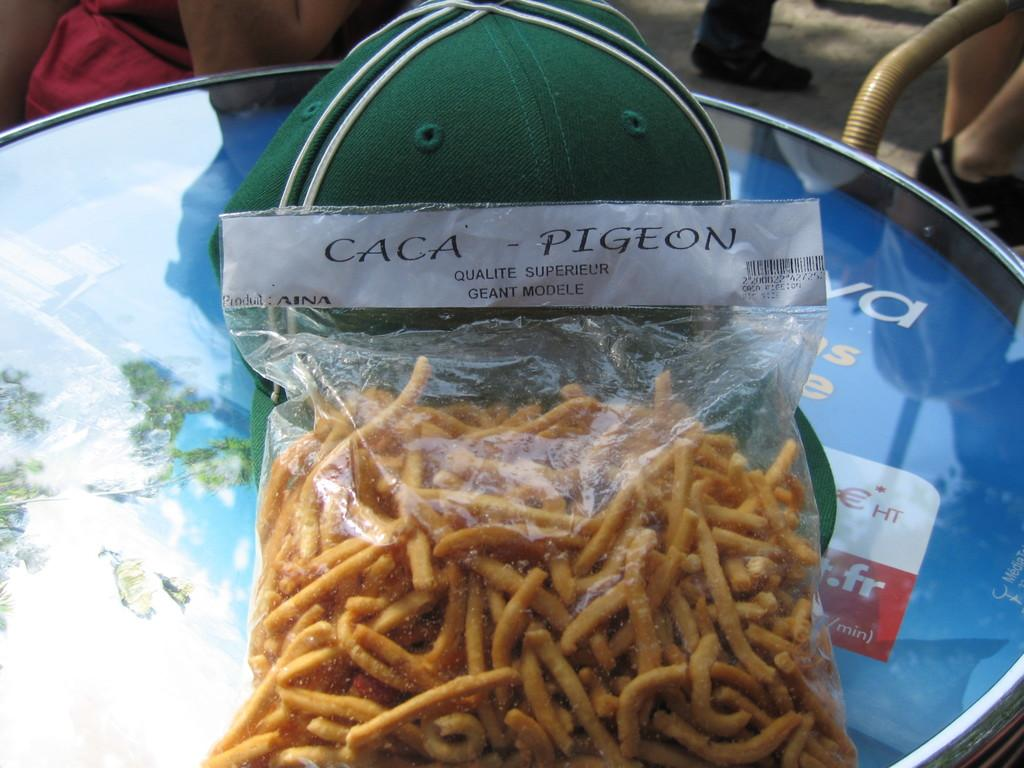What type of items can be seen in the image? There are food items in the image. How are the food items stored or contained? The food items are packed in a cover. Can you describe any specific feature of the cover? There is a green cap on the cover. How many passengers are visible in the image? There are no passengers present in the image; it only features food items packed in a cover with a green cap. 